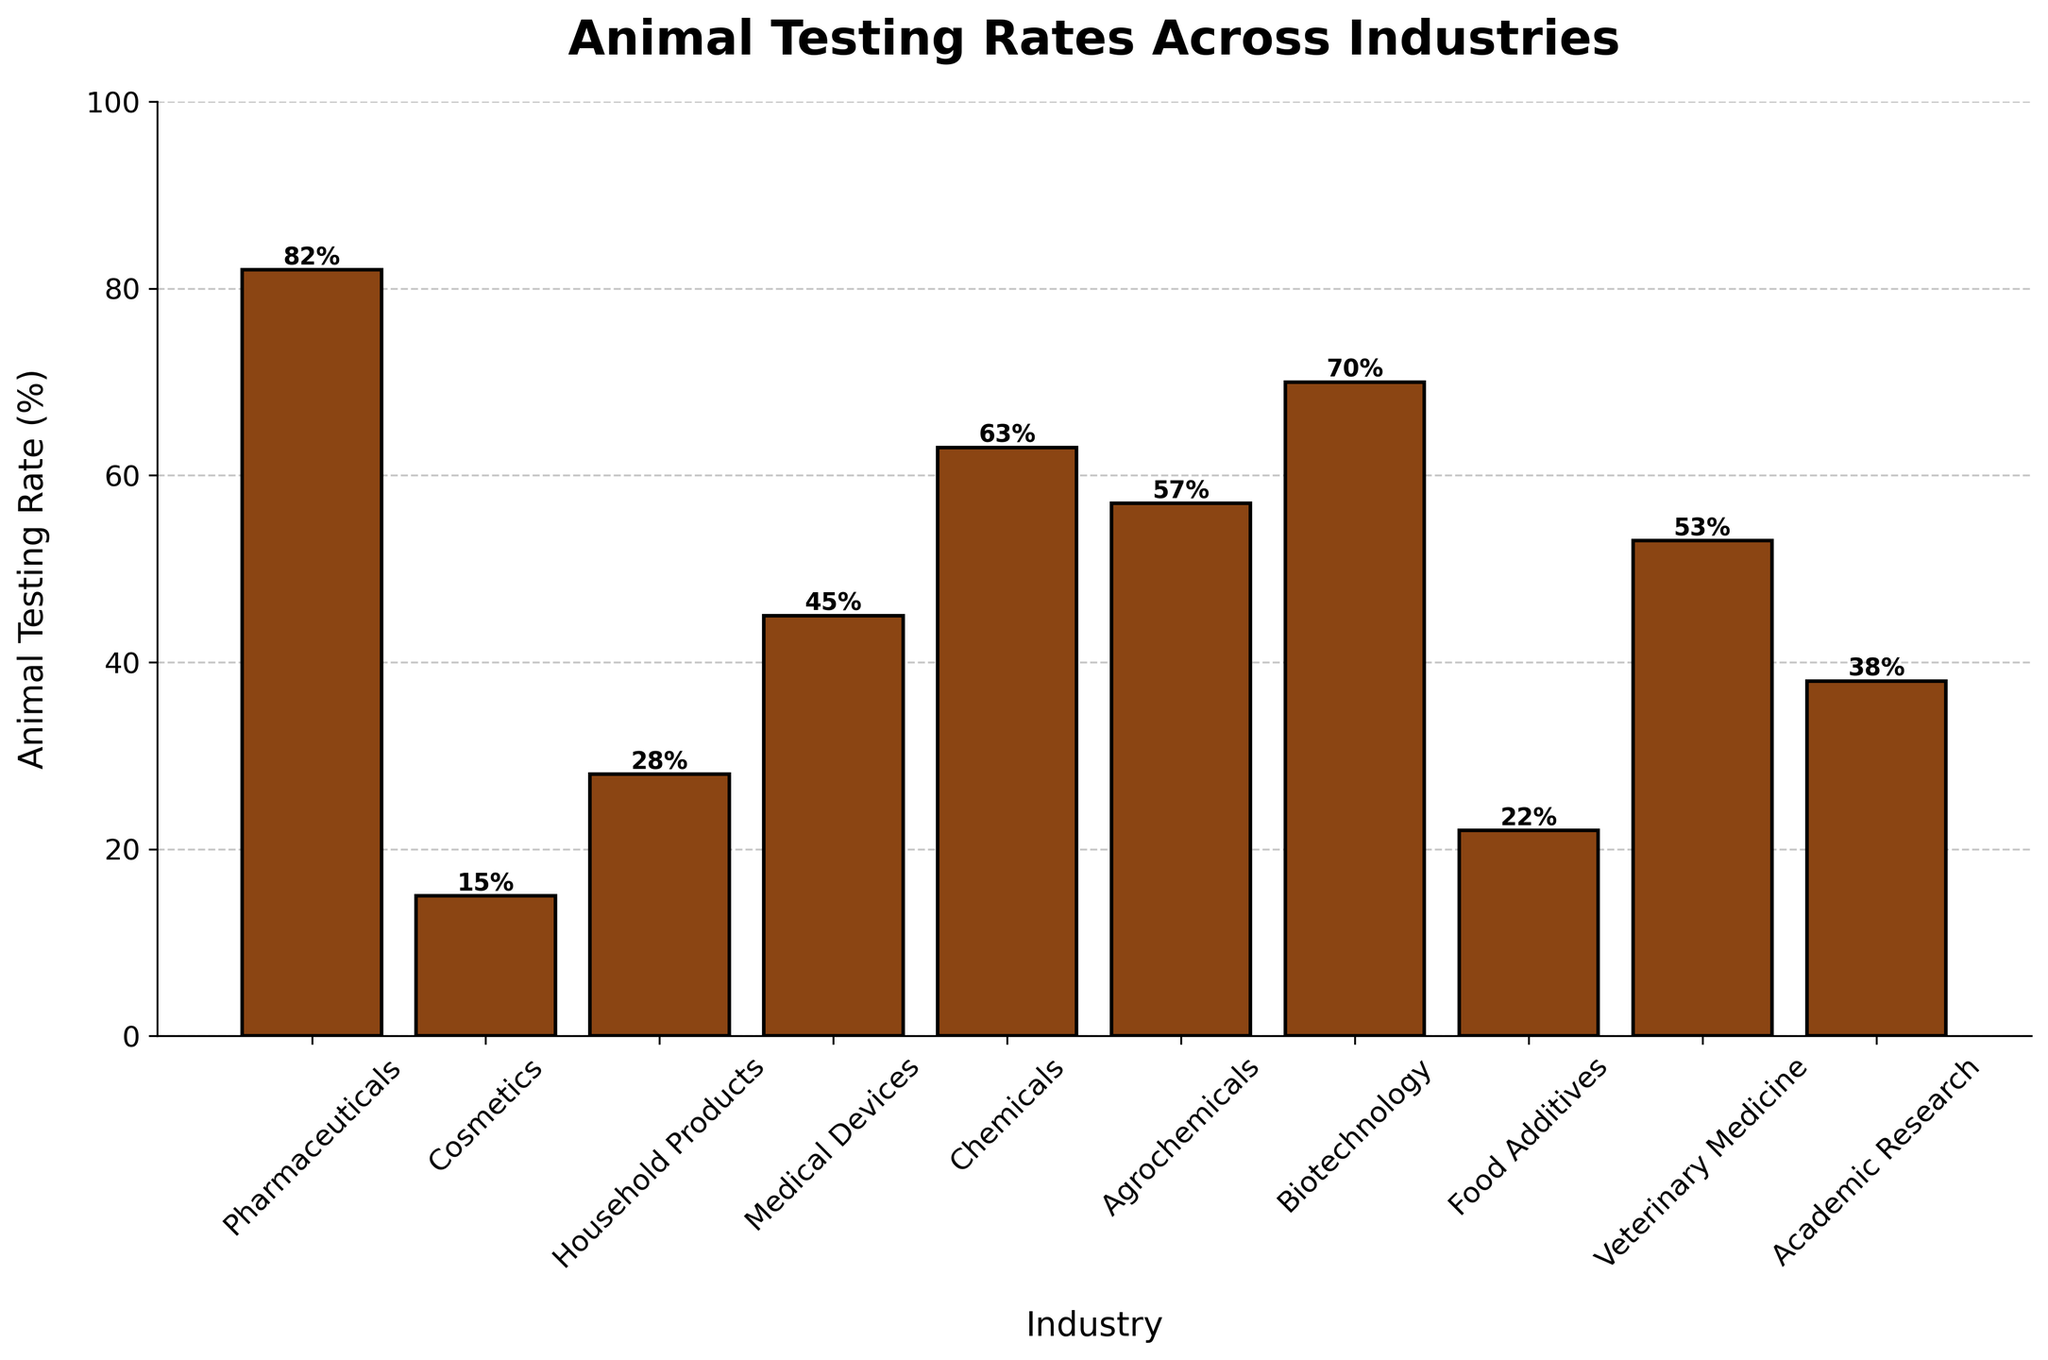Which industry has the highest animal testing rate? Find the bar with the greatest height. The highest bar belongs to Pharmaceuticals with a testing rate of 82%.
Answer: Pharmaceuticals Which industry has the lowest animal testing rate? Find the bar with the smallest height. The lowest bar belongs to Cosmetics with a testing rate of 15%.
Answer: Cosmetics How much higher is the animal testing rate in Pharmaceuticals compared to Food Additives? Subtract the height of the Food Additives bar (22%) from the Pharmaceuticals bar (82%). The difference is 82% - 22% = 60%.
Answer: 60% Which two industries have animal testing rates closest to each other? Compare the heights of the bars to find the two with the smallest absolute difference. Medical Devices (45%) and Academic Research (38%) have the smallest difference, which is 45% - 38% = 7%.
Answer: Medical Devices and Academic Research What is the average animal testing rate across all industries? Add all the animal testing rates and divide by the number of industries.
(82 + 15 + 28 + 45 + 63 + 57 + 70 + 22 + 53 + 38) / 10 = 47.3%
Answer: 47.3% How many industries have animal testing rates above 50%? Count the bars with a height greater than 50%. The industries are Pharmaceuticals, Chemicals, Agrochemicals, Biotechnology, and Veterinary Medicine, so there are 5 industries.
Answer: 5 What is the total animal testing rate for Medical Devices and Chemicals combined? Add the animal testing rates of Medical Devices (45%) and Chemicals (63%). The total is 45% + 63% = 108%.
Answer: 108% Is the animal testing rate for Biotechnology greater than the rate for Agrochemicals? Compare the heights of the Biotechnology bar (70%) and the Agrochemicals bar (57%). Yes, 70% is greater than 57%.
Answer: Yes Which industry has a slightly higher animal testing rate, Medical Devices or Veterinary Medicine? Compare the heights of the Medical Devices bar (45%) and the Veterinary Medicine bar (53%). Veterinary Medicine has a higher rate.
Answer: Veterinary Medicine What percentage point difference is there between the animal testing rates of Household Products and Food Additives? Subtract the height of the Food Additives bar (22%) from the Household Products bar (28%). The difference is 28% - 22% = 6%.
Answer: 6% 